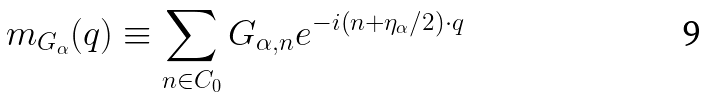Convert formula to latex. <formula><loc_0><loc_0><loc_500><loc_500>m _ { G _ { \alpha } } ( q ) \equiv \sum _ { n \in C _ { 0 } } G _ { \alpha , n } e ^ { - i ( n + \eta _ { \alpha } / 2 ) \cdot q }</formula> 